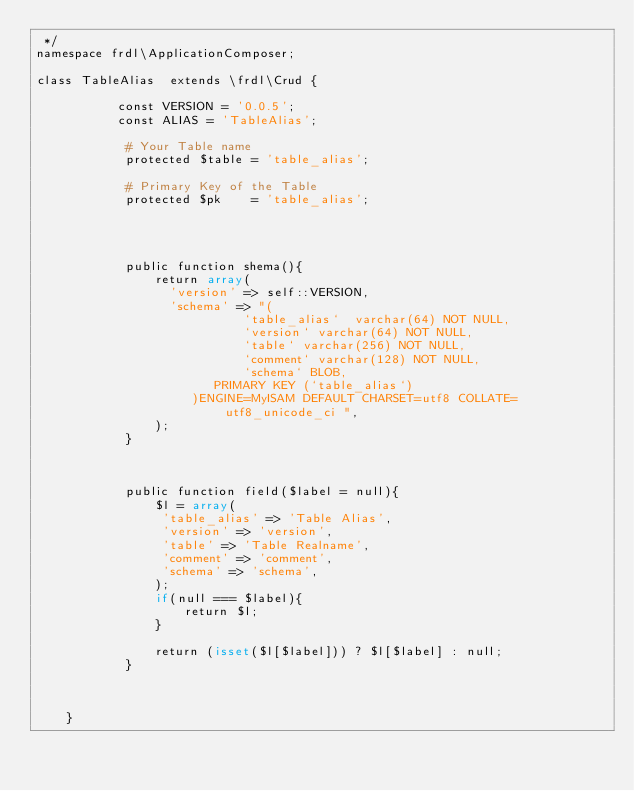<code> <loc_0><loc_0><loc_500><loc_500><_PHP_> */
namespace frdl\ApplicationComposer;
 
class TableAlias  extends \frdl\Crud {
		
		   const VERSION = '0.0.5';
		   const ALIAS = 'TableAlias';
		   
			# Your Table name 
			protected $table = 'table_alias';
			
			# Primary Key of the Table
			protected $pk	 = 'table_alias';
			

	
				
			public function shema(){
				return array(
				  'version' => self::VERSION,
				  'schema' => "(
                            `table_alias`  varchar(64) NOT NULL,
                            `version` varchar(64) NOT NULL,
                            `table` varchar(256) NOT NULL,
                            `comment` varchar(128) NOT NULL,
                            `schema` BLOB,
                        PRIMARY KEY (`table_alias`)
				     )ENGINE=MyISAM DEFAULT CHARSET=utf8 COLLATE=utf8_unicode_ci ",
				);
			}
			

			
	        public function field($label = null){
				$l = array(
				 'table_alias' => 'Table Alias',
				 'version' => 'version',
				 'table' => 'Table Realname',
				 'comment' => 'comment',
				 'schema' => 'schema',
				);
				if(null === $label){
					return $l;
				}
				
				return (isset($l[$label])) ? $l[$label] : null;
			}
			
	
			
	}</code> 